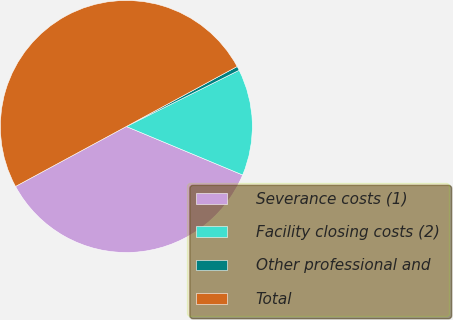<chart> <loc_0><loc_0><loc_500><loc_500><pie_chart><fcel>Severance costs (1)<fcel>Facility closing costs (2)<fcel>Other professional and<fcel>Total<nl><fcel>35.82%<fcel>13.65%<fcel>0.53%<fcel>50.0%<nl></chart> 